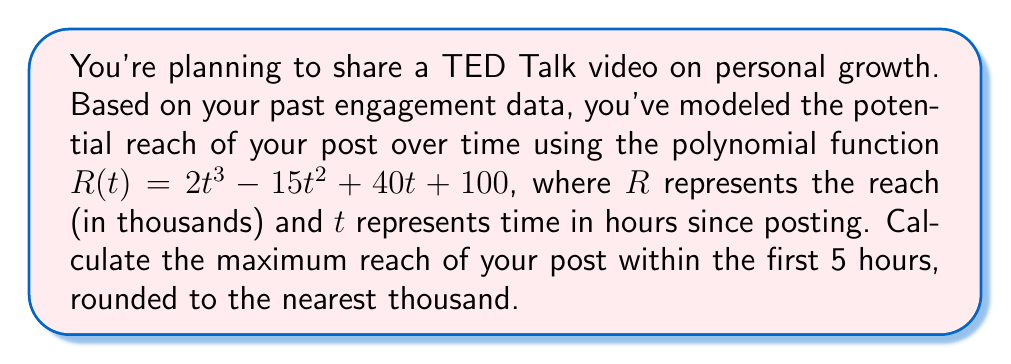Provide a solution to this math problem. To find the maximum reach within the first 5 hours, we need to follow these steps:

1) The function given is $R(t) = 2t^3 - 15t^2 + 40t + 100$

2) To find the maximum, we need to find the critical points within the interval [0, 5]. We do this by taking the derivative and setting it equal to zero:

   $R'(t) = 6t^2 - 30t + 40$

3) Set $R'(t) = 0$:
   $6t^2 - 30t + 40 = 0$

4) This is a quadratic equation. We can solve it using the quadratic formula:
   $t = \frac{-b \pm \sqrt{b^2 - 4ac}}{2a}$

   Where $a = 6$, $b = -30$, and $c = 40$

5) Substituting these values:
   $t = \frac{30 \pm \sqrt{900 - 960}}{12} = \frac{30 \pm \sqrt{-60}}{12}$

6) Since the square root of a negative number is not real, there are no critical points within the domain of real numbers.

7) This means the maximum must occur at one of the endpoints of our interval: $t = 0$ or $t = 5$

8) Calculate $R(0)$ and $R(5)$:
   $R(0) = 100$
   $R(5) = 2(5^3) - 15(5^2) + 40(5) + 100 = 250 - 375 + 200 + 100 = 175$

9) The larger value is $R(5) = 175$, so this is our maximum.

10) 175 thousand rounded to the nearest thousand is 175 thousand.
Answer: 175,000 